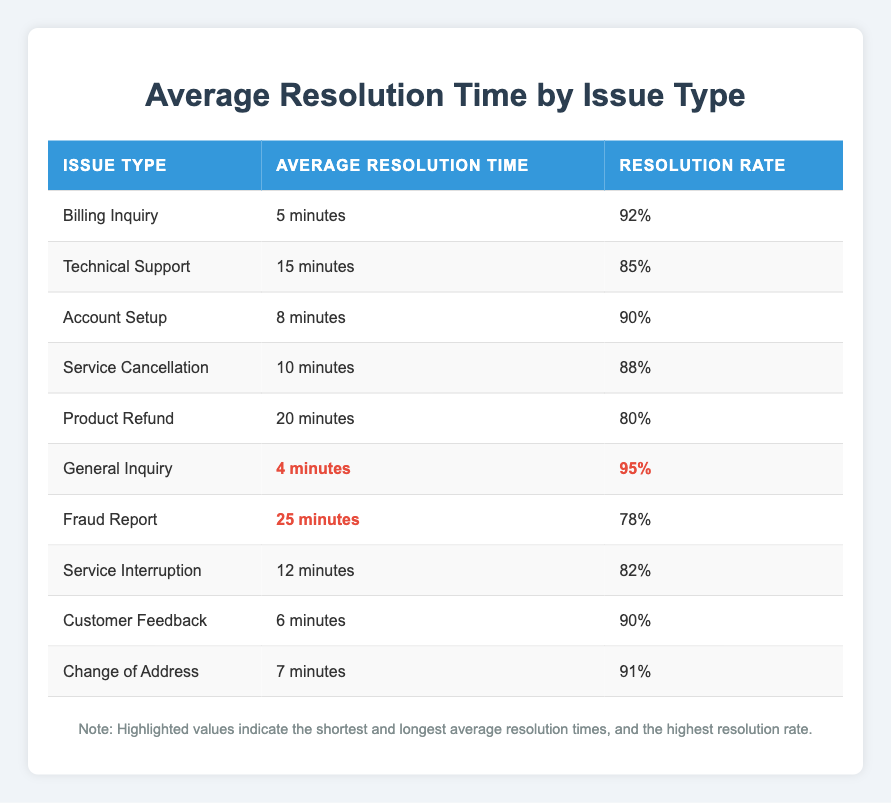What is the average resolution time for a Technical Support issue? The table lists "Technical Support" with an average resolution time of "15 minutes."
Answer: 15 minutes Which issue type has the highest resolution rate? The table shows that "General Inquiry" has a resolution rate of "95%", which is higher than all other issue types.
Answer: General Inquiry What is the average resolution time for billing inquiries compared to service interruptions? The table shows that "Billing Inquiry" has an average resolution time of "5 minutes" and "Service Interruption" has "12 minutes." The difference is 12 - 5 = 7 minutes.
Answer: 7 minutes Is the average resolution time for a fraud report greater than or equal to 20 minutes? The table lists the average resolution time for "Fraud Report" as "25 minutes," which is greater than 20 minutes.
Answer: Yes What is the total average resolution time for Customer Feedback and Change of Address issues combined? The average resolution time for "Customer Feedback" is "6 minutes" and for "Change of Address" it is "7 minutes." Therefore, the total is 6 + 7 = 13 minutes.
Answer: 13 minutes How much longer, on average, does it take to resolve a Product Refund issue compared to a General Inquiry? The average resolution time for "Product Refund" is "20 minutes" and for "General Inquiry" it is "4 minutes." The difference is 20 - 4 = 16 minutes.
Answer: 16 minutes Which issue type has the longest average resolution time? The table indicates that "Fraud Report," with an average resolution time of "25 minutes," is the longest among all issue types listed.
Answer: Fraud Report What percentage of resolution rates is lower: Technical Support or Product Refund? The table shows "Technical Support" with a resolution rate of "85%" and "Product Refund" with "80%." Since 80% is lower than 85%, the answer is "Product Refund."
Answer: Product Refund If you were to average the resolution times of all issues, what would be the total duration? The average resolution times are: 5 (Billing Inquiry) + 15 (Technical Support) + 8 (Account Setup) + 10 (Service Cancellation) + 20 (Product Refund) + 4 (General Inquiry) + 25 (Fraud Report) + 12 (Service Interruption) + 6 (Customer Feedback) + 7 (Change of Address) = 112 minutes. The average resolution time across 10 issues is 112 / 10 = 11.2 minutes.
Answer: 11.2 minutes How many issue types have an average resolution time of less than or equal to 10 minutes? From the table, the issue types with less than or equal to 10 minutes are: "Billing Inquiry" (5 minutes), "Account Setup" (8 minutes), "Service Cancellation" (10 minutes), "General Inquiry" (4 minutes), "Customer Feedback" (6 minutes), and "Change of Address" (7 minutes); this totals 6 issue types.
Answer: 6 types Which two issue types have an average resolution time of 8 minutes or less? Reviewing the table, "Billing Inquiry" (5 minutes), "General Inquiry" (4 minutes), and "Customer Feedback" (6 minutes) are below 8 minutes. Thus, we can select "Billing Inquiry" and "General Inquiry" as two such types.
Answer: Billing Inquiry and General Inquiry 